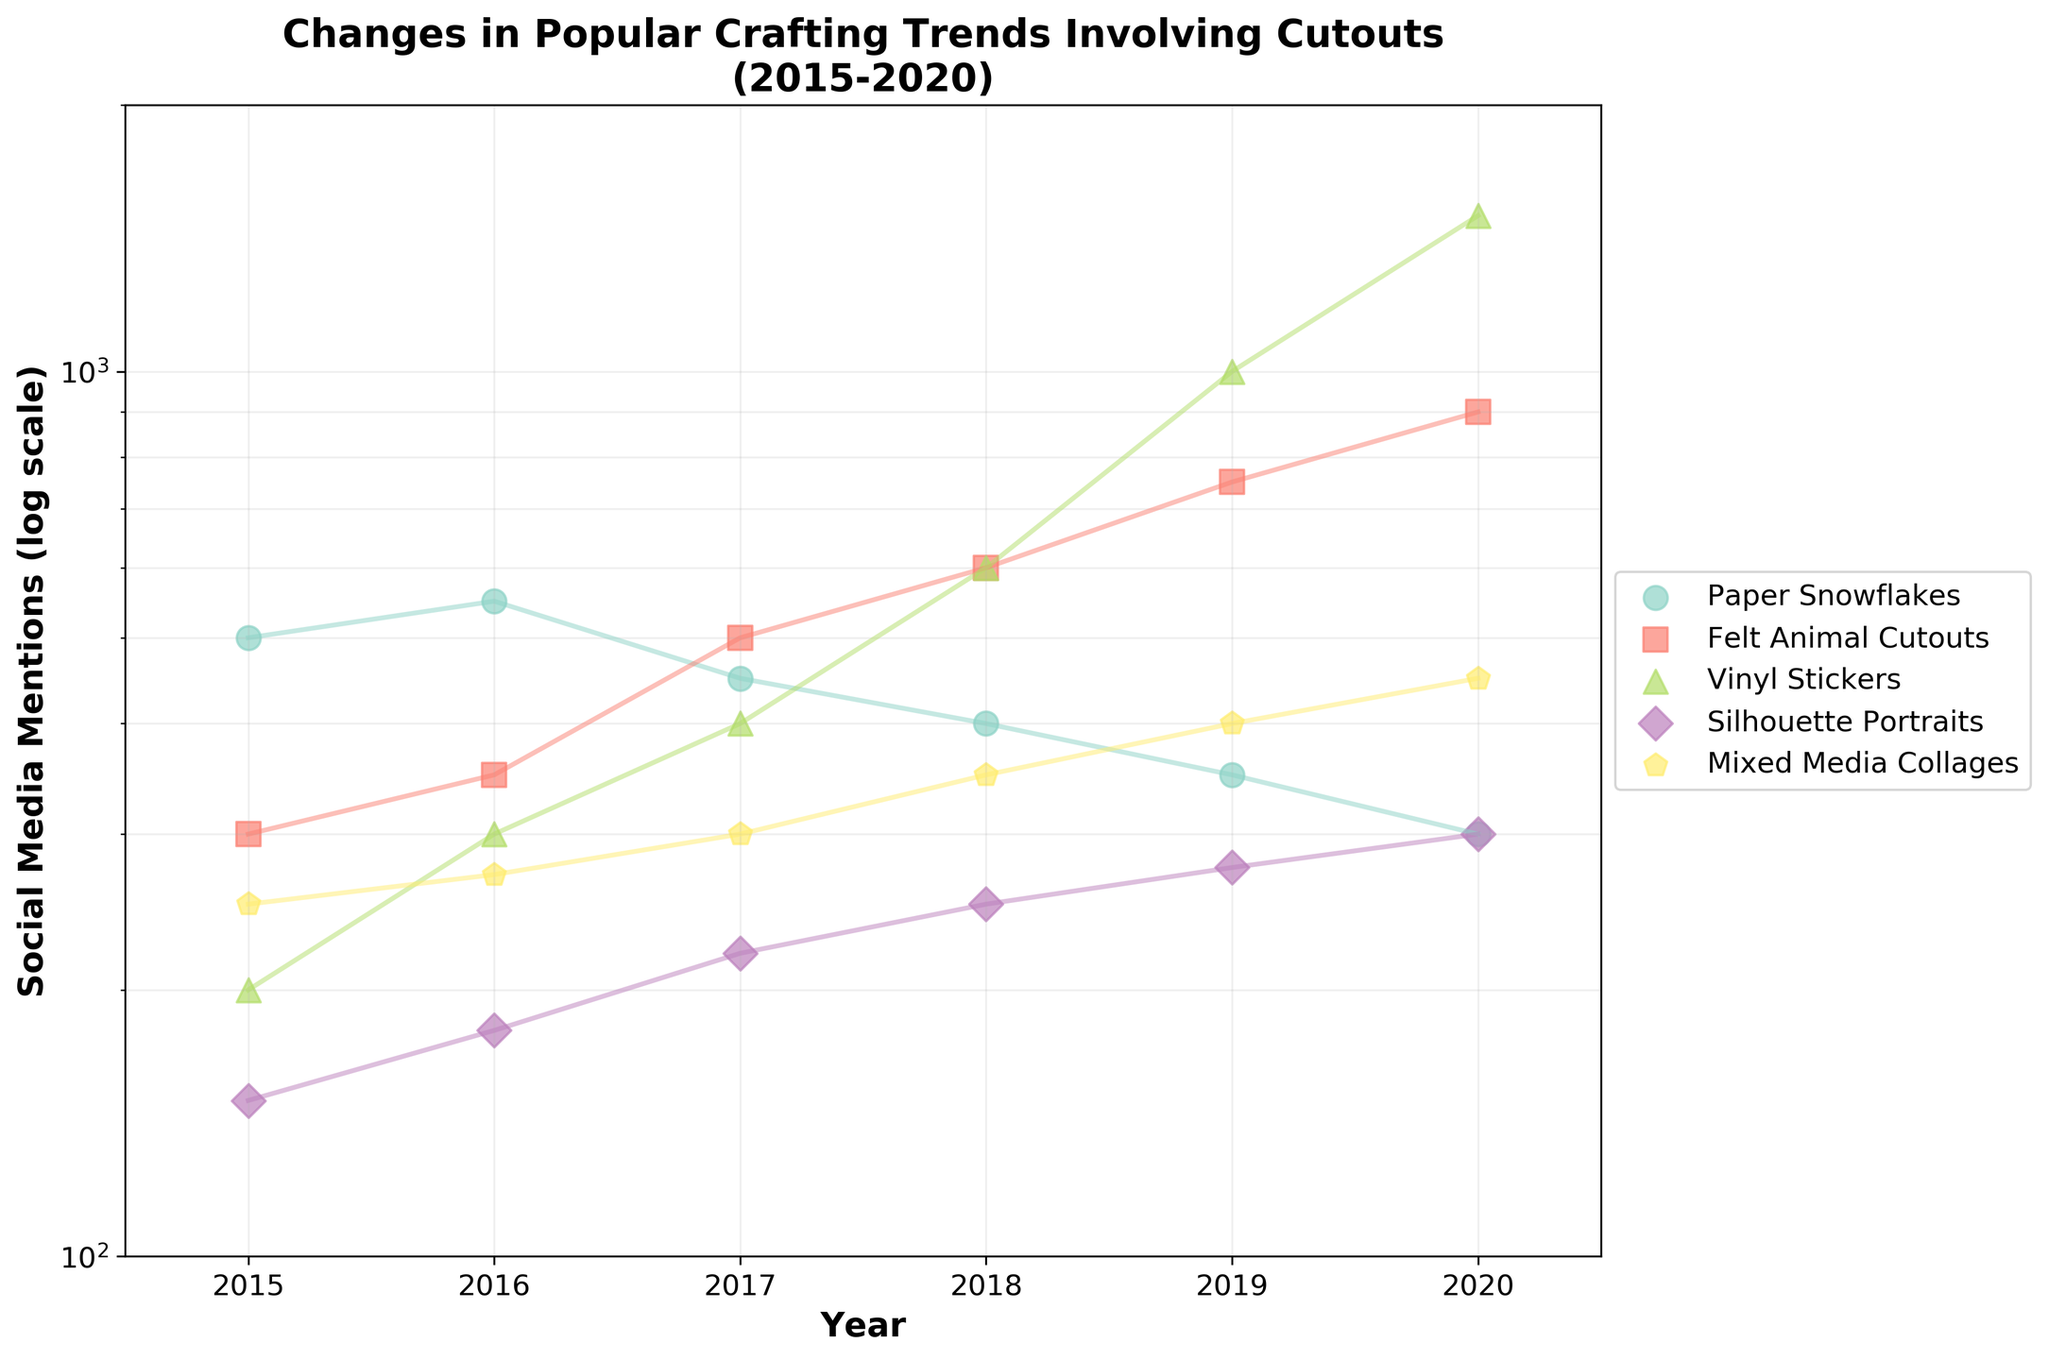How many different crafting trends are displayed in the figure? The figure shows 5 different crafting trends, as indicated by the unique colors and markers. They are also listed in the legend.
Answer: 5 Which crafting trend has the highest number of social media mentions in 2020? By looking at the topmost point in the year 2020, the trend with the highest number of social media mentions is "Vinyl Stickers" with 1500 mentions.
Answer: Vinyl Stickers What is the overall trend observed for "Paper Snowflakes" in terms of social media mentions from 2015 to 2020? "Paper Snowflakes" show a declining trend in social media mentions, starting from 500 in 2015 and decreasing to 300 in 2020.
Answer: Declining Which two crafting trends had almost the same number of social media mentions in 2017? By visually inspecting the points for the year 2017, "Felt Animal Cutouts" and "Paper Snowflakes" both had around 450-500 mentions.
Answer: Felt Animal Cutouts, Paper Snowflakes Between which years did "Vinyl Stickers" see the largest relative increase in social media mentions? The largest jump for "Vinyl Stickers" was from 2018 (600 mentions) to 2019 (1000 mentions), an increase by 400 mentions.
Answer: 2018-2019 Which crafting trend shows a steadily increasing trend in mentions on social media over the years? "Felt Animal Cutouts" shows a steadily increasing trend from 300 mentions in 2015 to 900 mentions in 2020.
Answer: Felt Animal Cutouts In which year did "Mixed Media Collages" first reach at least 350 mentions? "Mixed Media Collages" reached 350 mentions for the first time in 2018.
Answer: 2018 How does the growth rate of "Silhouette Portraits" from 2015 to 2020 compare to the growth rate of "Vinyl Stickers"? "Silhouette Portraits" grew from 150 to 300 mentions, while "Vinyl Stickers" grew from 200 to 1500 mentions, indicating "Vinyl Stickers" had a much higher growth rate.
Answer: Vinyl Stickers grew faster What can be inferred about the popularity of "Felt Animal Cutouts" compared to "Paper Snowflakes" over these years? "Felt Animal Cutouts" increased in popularity significantly from 300 to 900 mentions, while "Paper Snowflakes" declined from 500 to 300 mentions, showing "Felt Animal Cutouts" became more popular over time.
Answer: Felt Animal Cutouts became more popular What pattern do you observe about the scale used for the Y-axis, and why might this be useful? The Y-axis uses a log scale, which is useful for displaying a wide range of values more clearly and helps to see growth patterns on a multiplicative scale.
Answer: Log scale, useful for displaying a wide range of values 